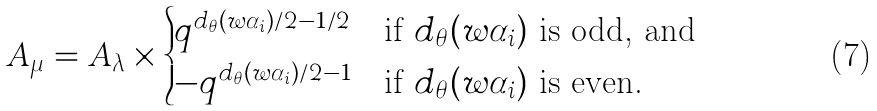Convert formula to latex. <formula><loc_0><loc_0><loc_500><loc_500>A _ { \mu } = A _ { \lambda } \times \begin{cases} q ^ { d _ { \theta } ( w \alpha _ { i } ) / 2 - 1 / 2 } & \text {if $d_{\theta } (w\alpha_{i})$ is odd, and} \\ - q ^ { d _ { \theta } ( w \alpha _ { i } ) / 2 - 1 } & \text {if $d_{\theta } (w\alpha_{i})$ is even.} \end{cases}</formula> 